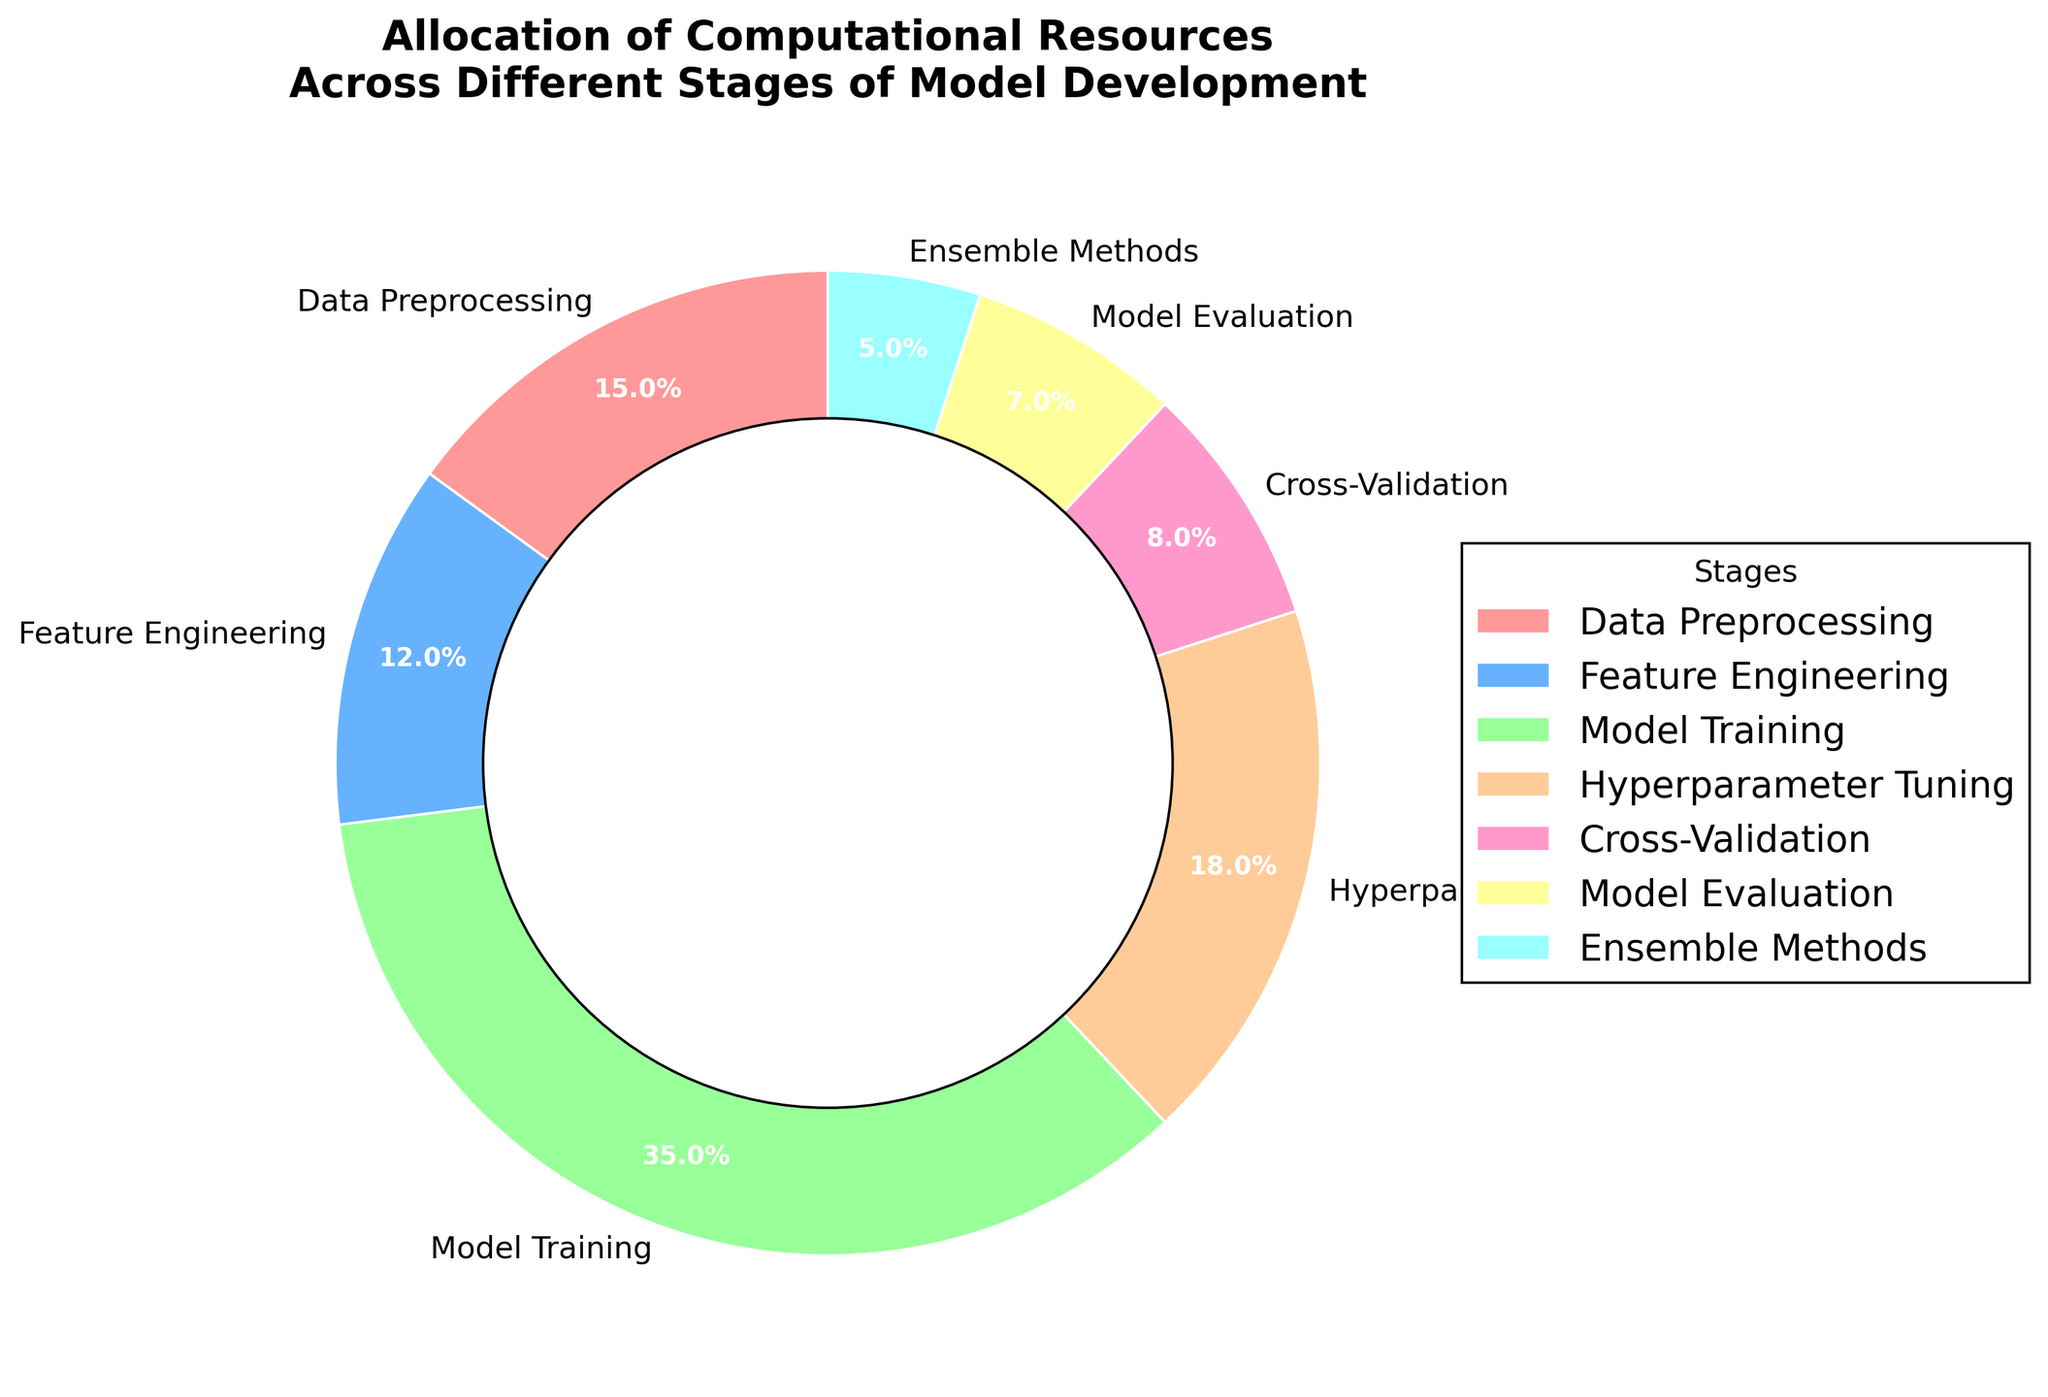Which stage of model development uses the highest percentage of computational resources? From the pie chart, the stage with the largest wedge and highest percentage is Model Training. This can be confirmed by looking at the percentages provided, with Model Training at 35%.
Answer: Model Training What is the total percentage of computational resources allocated to Hyperparameter Tuning and Cross-Validation? Add the percentages for Hyperparameter Tuning (18%) and Cross-Validation (8%). The sum is 18% + 8% = 26%.
Answer: 26% How much more computational resources are allocated to Data Preprocessing compared to Ensemble Methods? Subtract the percentage of Ensemble Methods (5%) from Data Preprocessing (15%). The difference is 15% - 5% = 10%.
Answer: 10% Which stages collectively use exactly half of the computational resources? Sum the percentages of different combinations until you find a combination that equals 50%. Adding Model Training (35%) and Hyperparameter Tuning (18%) gives 53%, while Model Training (35%) and Data Preprocessing (15%) gives 50%.
Answer: Model Training and Data Preprocessing What percentage of computational resources is allocated to tasks other than Model Training? Subtract the percentage of Model Training (35%) from 100%. The remaining percentage is 100% - 35% = 65%.
Answer: 65% Which stage has the smallest allocation of computational resources? From the pie chart, the smallest wedge and percentage belong to Ensemble Methods, which is 5%.
Answer: Ensemble Methods How do the computational resources for Model Evaluation compare to Feature Engineering? The percentage for Model Evaluation is 7%, and for Feature Engineering, it is 12%. Comparison shows that Model Evaluation uses less computational resources than Feature Engineering by 5%.
Answer: Model Evaluation uses 5% less What is the combined percentage allocation for the stages with the two least computational resources? Add the percentages of Model Evaluation (7%) and Ensemble Methods (5%) which are the two smallest allocations. The combined allocation is 7% + 5% = 12%.
Answer: 12% Which is larger in terms of computational resources allocation: Hyperparameter Tuning or Feature Engineering? From the chart, Hyperparameter Tuning is 18% and Feature Engineering is 12%. Hyperparameter Tuning has a larger allocation than Feature Engineering.
Answer: Hyperparameter Tuning If you were to redistribute 10% of computational resources from Model Training to Data Preprocessing, what would be the new percentage allocation for these two stages? If we subtract 10% from Model Training (35%), it becomes 25%. Adding this 10% to Data Preprocessing (15%) makes it 25%.
Answer: Model Training: 25%, Data Preprocessing: 25% 